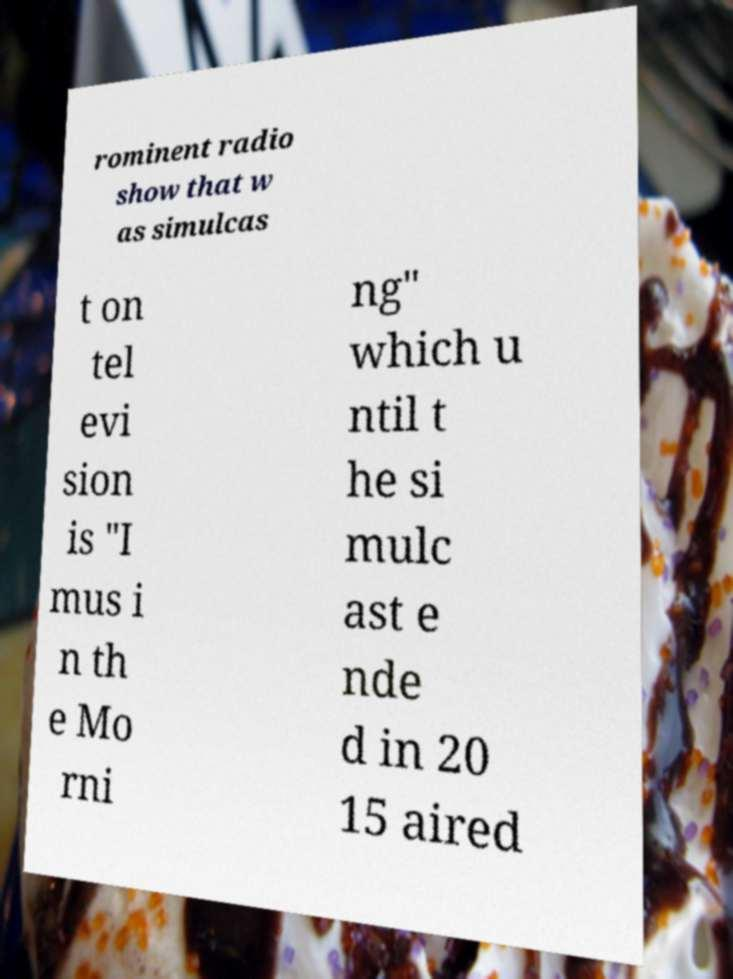For documentation purposes, I need the text within this image transcribed. Could you provide that? rominent radio show that w as simulcas t on tel evi sion is "I mus i n th e Mo rni ng" which u ntil t he si mulc ast e nde d in 20 15 aired 